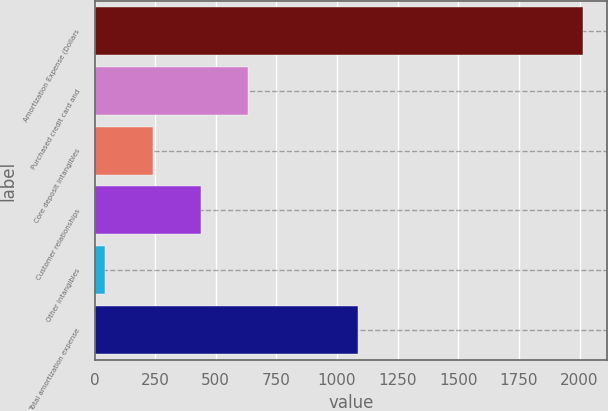Convert chart to OTSL. <chart><loc_0><loc_0><loc_500><loc_500><bar_chart><fcel>Amortization Expense (Dollars<fcel>Purchased credit card and<fcel>Core deposit intangibles<fcel>Customer relationships<fcel>Other intangibles<fcel>Total amortization expense<nl><fcel>2013<fcel>634<fcel>240<fcel>437<fcel>43<fcel>1086<nl></chart> 